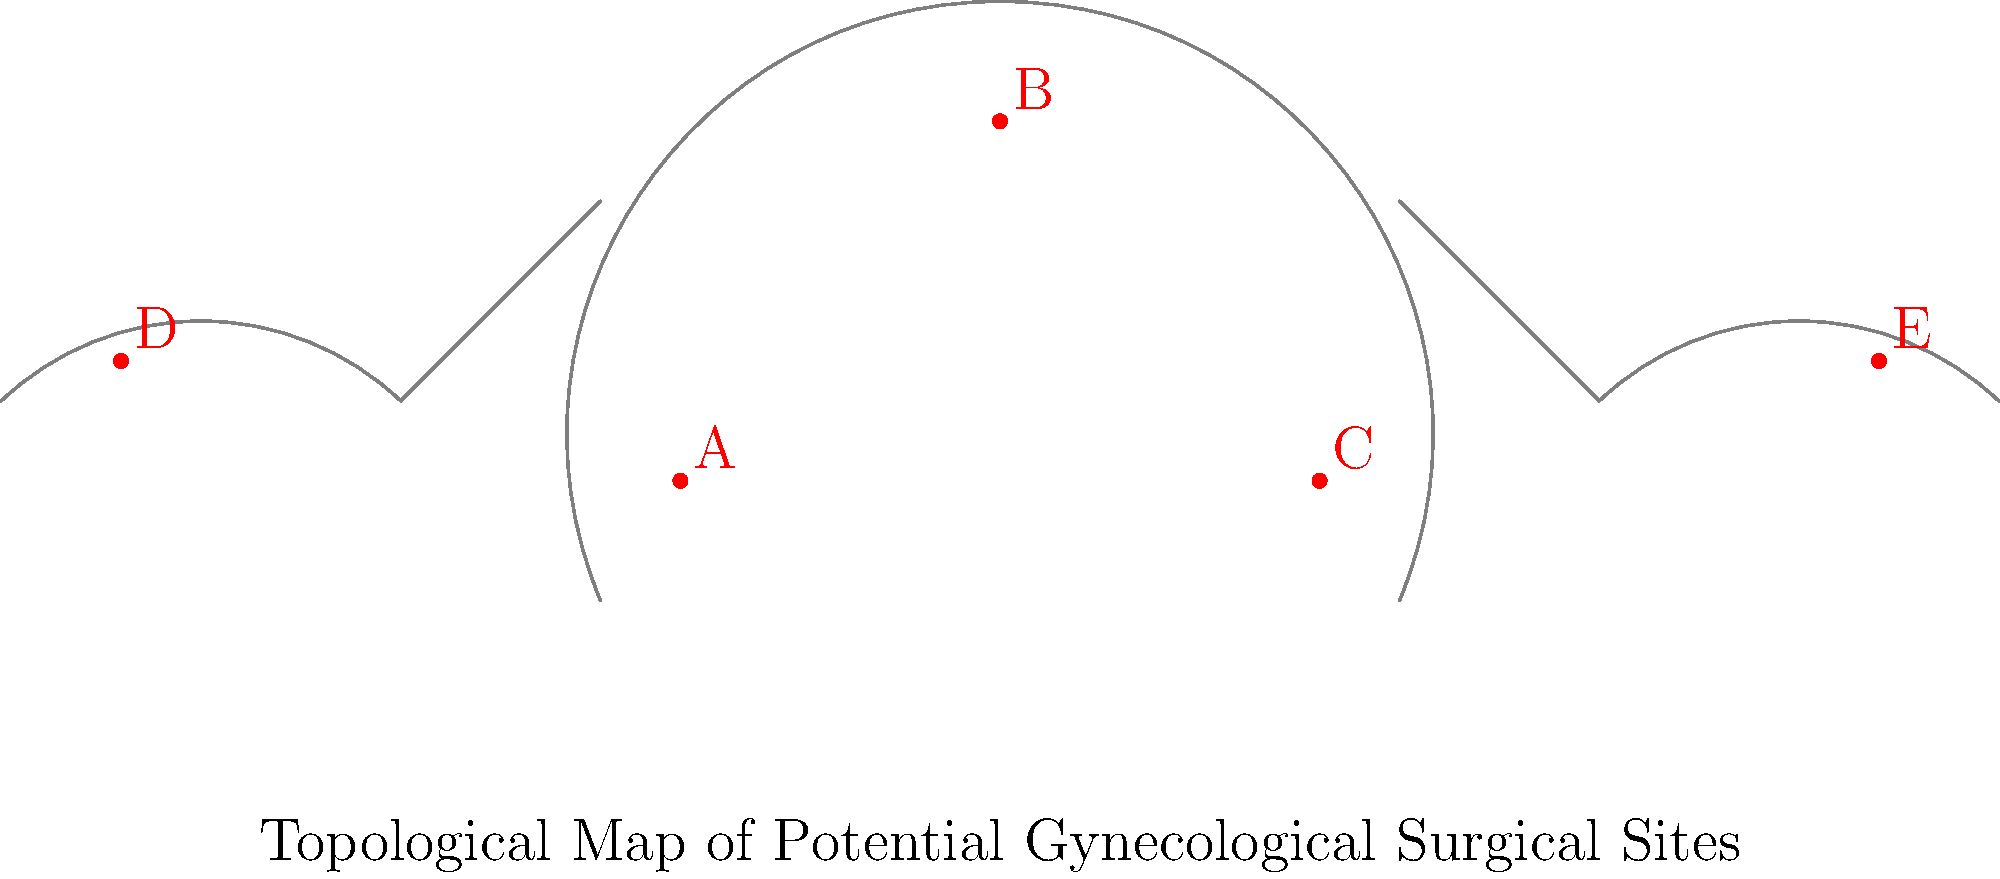Based on the topological map of potential gynecological surgical sites, which site would most likely be used for a hysterectomy procedure? To determine the most likely site for a hysterectomy procedure, let's analyze each labeled site on the topological map:

1. Site A: Located in the lower part of the uterus, near the cervix.
2. Site B: Positioned at the top of the uterus, in the fundus region.
3. Site C: Situated in the lower part of the uterus, opposite to site A.
4. Site D: Located in the left ovary region.
5. Site E: Positioned in the right ovary region.

A hysterectomy is a surgical procedure to remove the uterus. The procedure can be performed in different ways, but the primary target is always the uterus itself. 

Given this information:
- Sites D and E can be eliminated as they are located in the ovary regions, not in the uterus.
- Sites A and C are located in the lower part of the uterus, which could be potential entry points for some hysterectomy techniques, but they are not the primary target.
- Site B is positioned at the top of the uterus, in the fundus region. This is a central location that would likely be involved in any type of hysterectomy procedure, as it represents the main body of the uterus.

Therefore, site B is the most likely to be used for a hysterectomy procedure, as it represents the central part of the uterus that would need to be removed during the surgery.
Answer: B 